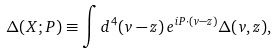<formula> <loc_0><loc_0><loc_500><loc_500>\Delta ( X ; P ) \equiv \int d ^ { 4 } ( v - z ) \, e ^ { i P \cdot ( v - z ) } \Delta ( v , z ) ,</formula> 